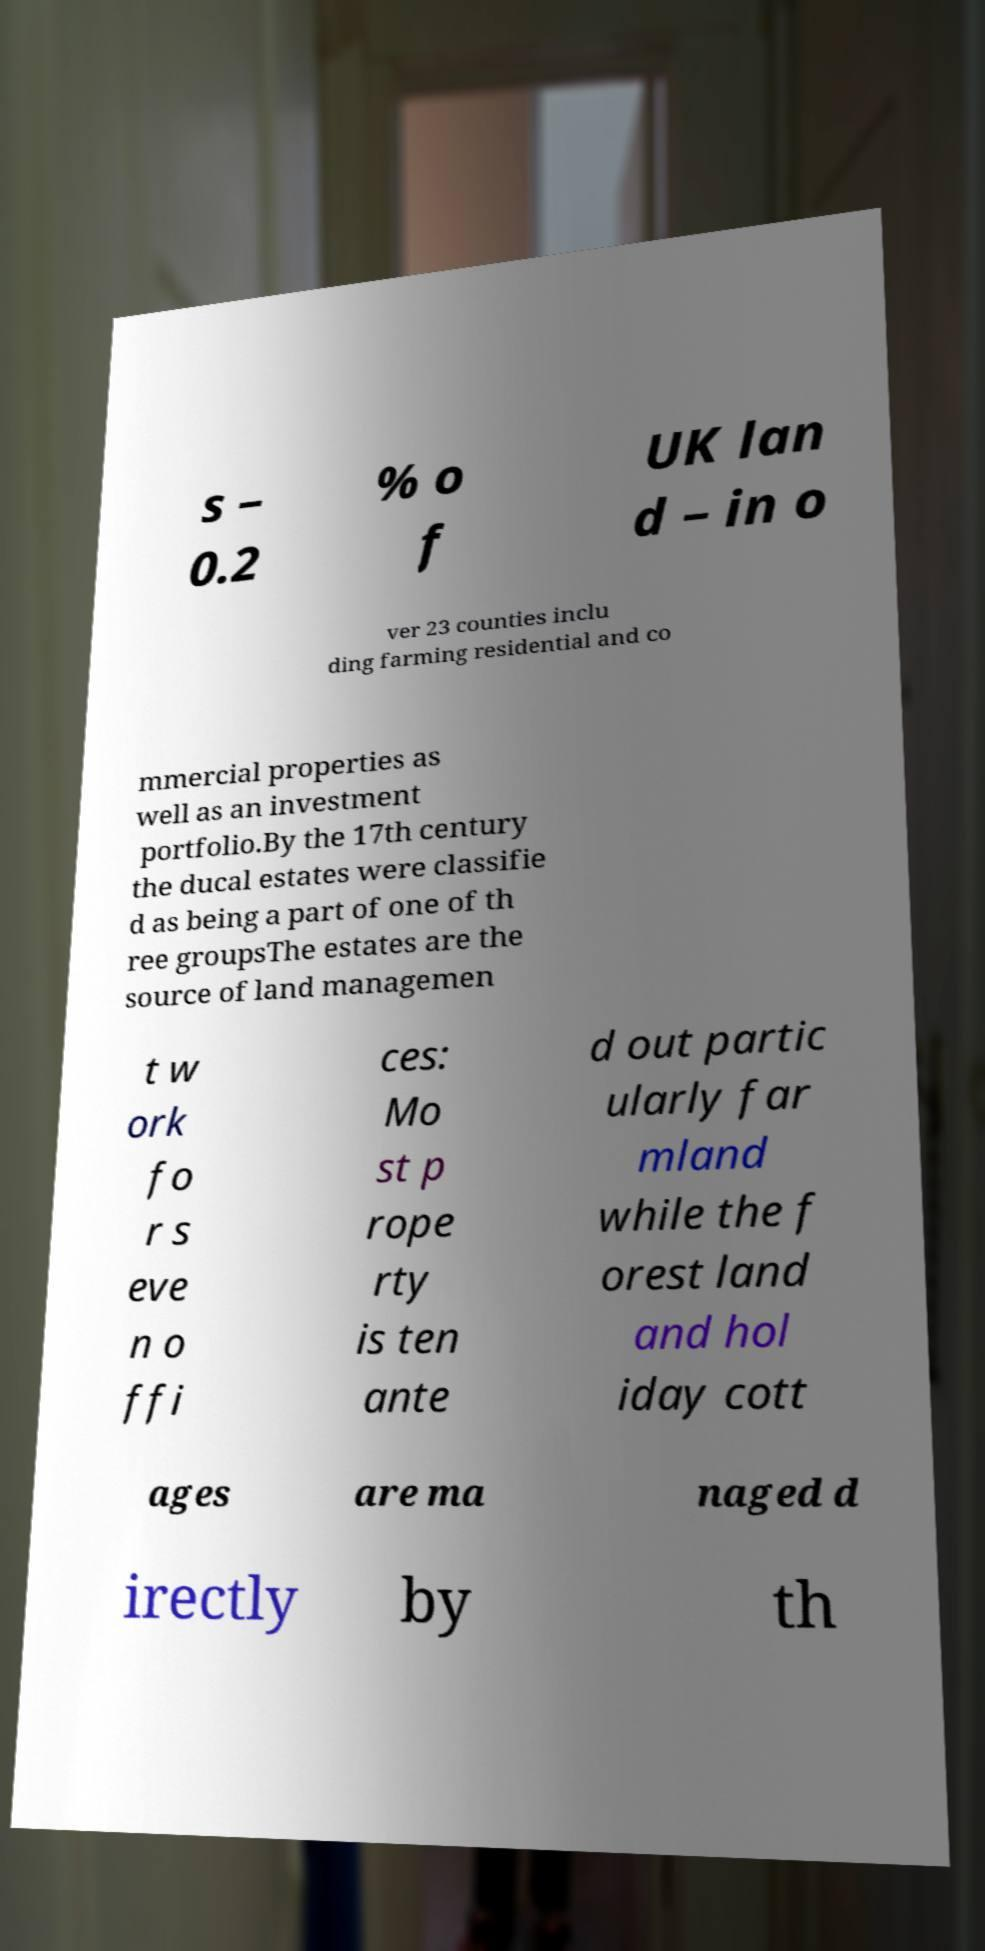Please identify and transcribe the text found in this image. s – 0.2 % o f UK lan d – in o ver 23 counties inclu ding farming residential and co mmercial properties as well as an investment portfolio.By the 17th century the ducal estates were classifie d as being a part of one of th ree groupsThe estates are the source of land managemen t w ork fo r s eve n o ffi ces: Mo st p rope rty is ten ante d out partic ularly far mland while the f orest land and hol iday cott ages are ma naged d irectly by th 